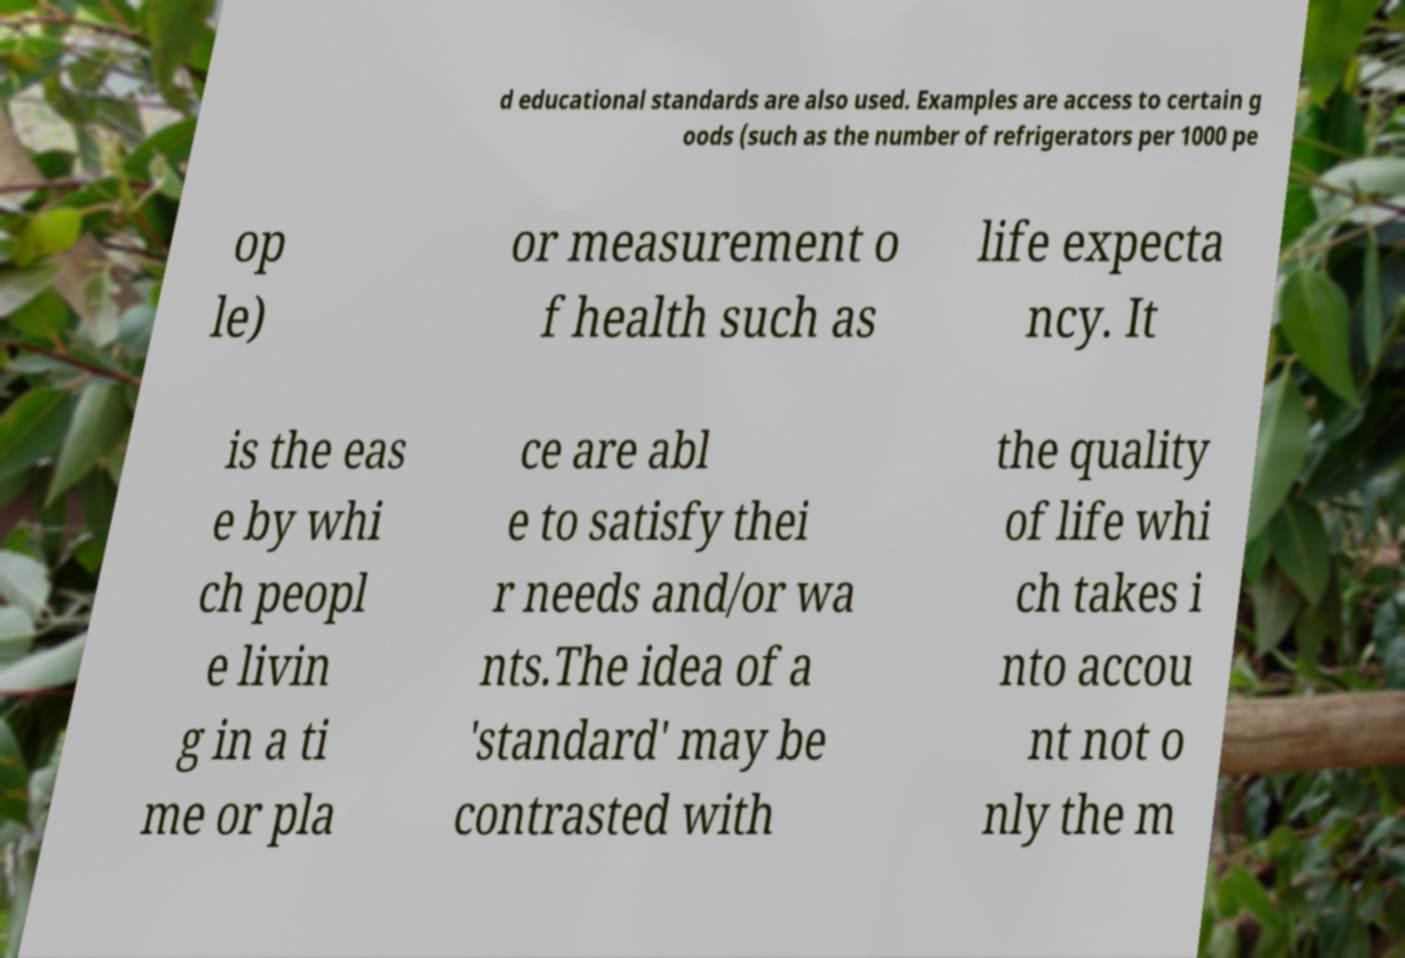Please identify and transcribe the text found in this image. d educational standards are also used. Examples are access to certain g oods (such as the number of refrigerators per 1000 pe op le) or measurement o f health such as life expecta ncy. It is the eas e by whi ch peopl e livin g in a ti me or pla ce are abl e to satisfy thei r needs and/or wa nts.The idea of a 'standard' may be contrasted with the quality of life whi ch takes i nto accou nt not o nly the m 